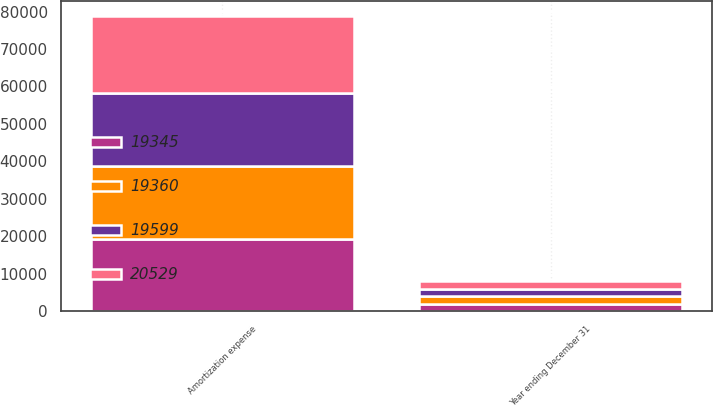<chart> <loc_0><loc_0><loc_500><loc_500><stacked_bar_chart><ecel><fcel>Year ending December 31<fcel>Amortization expense<nl><fcel>20529<fcel>2018<fcel>20529<nl><fcel>19599<fcel>2019<fcel>19599<nl><fcel>19360<fcel>2020<fcel>19360<nl><fcel>19345<fcel>2021<fcel>19345<nl></chart> 